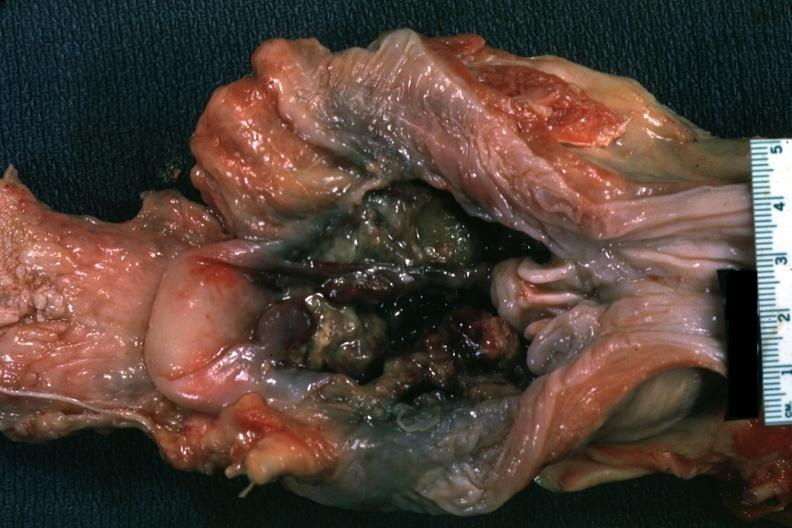does this image show unopened larynx viewed from hypopharynx mass of necrotic tissue?
Answer the question using a single word or phrase. Yes 